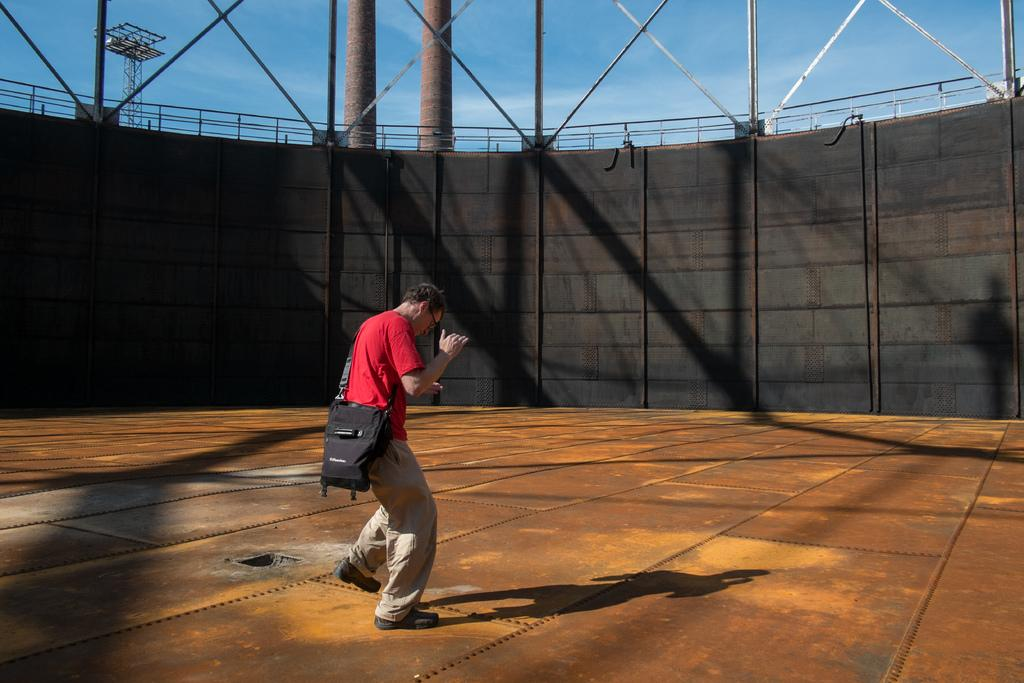What can be seen in the image? There are men standing in the image. What are the men wearing? The men are wearing bags across their bodies. What can be seen in the background of the image? There are walls, grills, a tower, and the sky visible in the background of the image. What is the condition of the sky in the image? The sky is visible in the background of the image, and clouds are present. What type of design can be seen on the pizzas in the image? There are no pizzas present in the image, so it is not possible to determine the design on any pizzas. Can you tell me how many snakes are visible in the image? There are no snakes present in the image. 